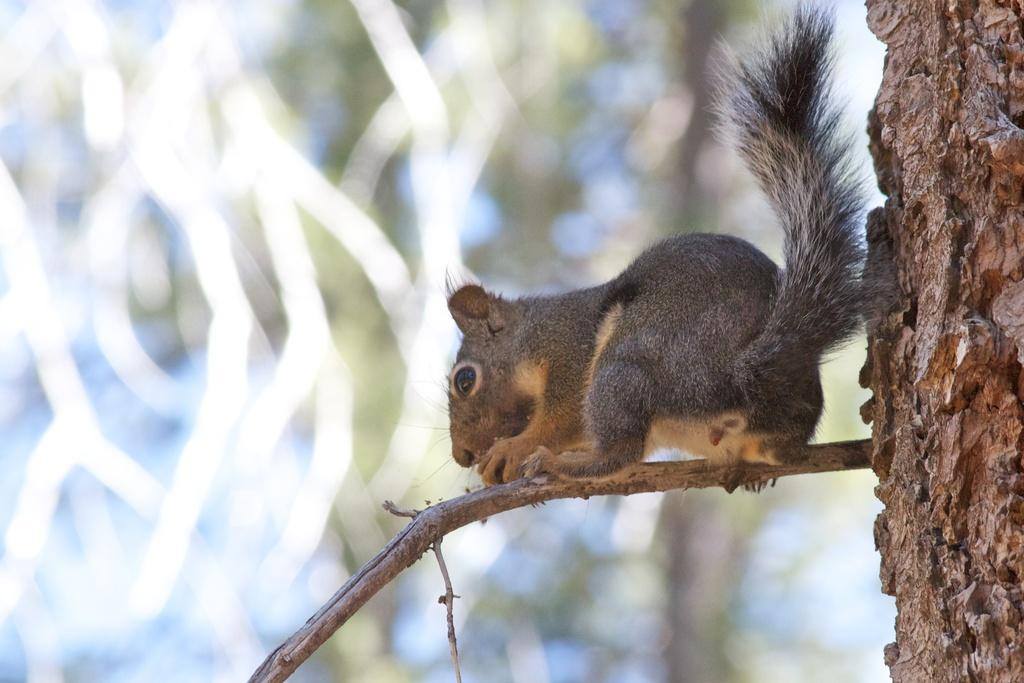What animal can be seen in the image? There is a squirrel in the image. Where is the squirrel located? The squirrel is on the branch of a tree. What is the weight of the fact in the image? There is no fact present in the image, and therefore no weight can be assigned to it. 